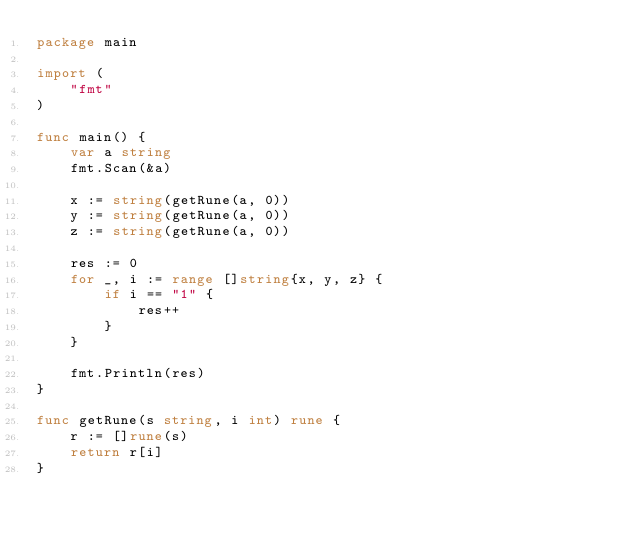<code> <loc_0><loc_0><loc_500><loc_500><_Go_>package main

import (
	"fmt"
)

func main() {
	var a string
	fmt.Scan(&a)

	x := string(getRune(a, 0))
	y := string(getRune(a, 0))
	z := string(getRune(a, 0))

	res := 0
	for _, i := range []string{x, y, z} {
		if i == "1" {
			res++
		}
	}

	fmt.Println(res)
}

func getRune(s string, i int) rune {
	r := []rune(s)
	return r[i]
}
</code> 